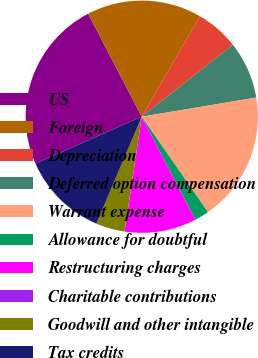Convert chart to OTSL. <chart><loc_0><loc_0><loc_500><loc_500><pie_chart><fcel>US<fcel>Foreign<fcel>Depreciation<fcel>Deferred option compensation<fcel>Warrant expense<fcel>Allowance for doubtful<fcel>Restructuring charges<fcel>Charitable contributions<fcel>Goodwill and other intangible<fcel>Tax credits<nl><fcel>23.98%<fcel>15.99%<fcel>6.01%<fcel>8.0%<fcel>17.99%<fcel>2.01%<fcel>10.0%<fcel>0.02%<fcel>4.01%<fcel>12.0%<nl></chart> 